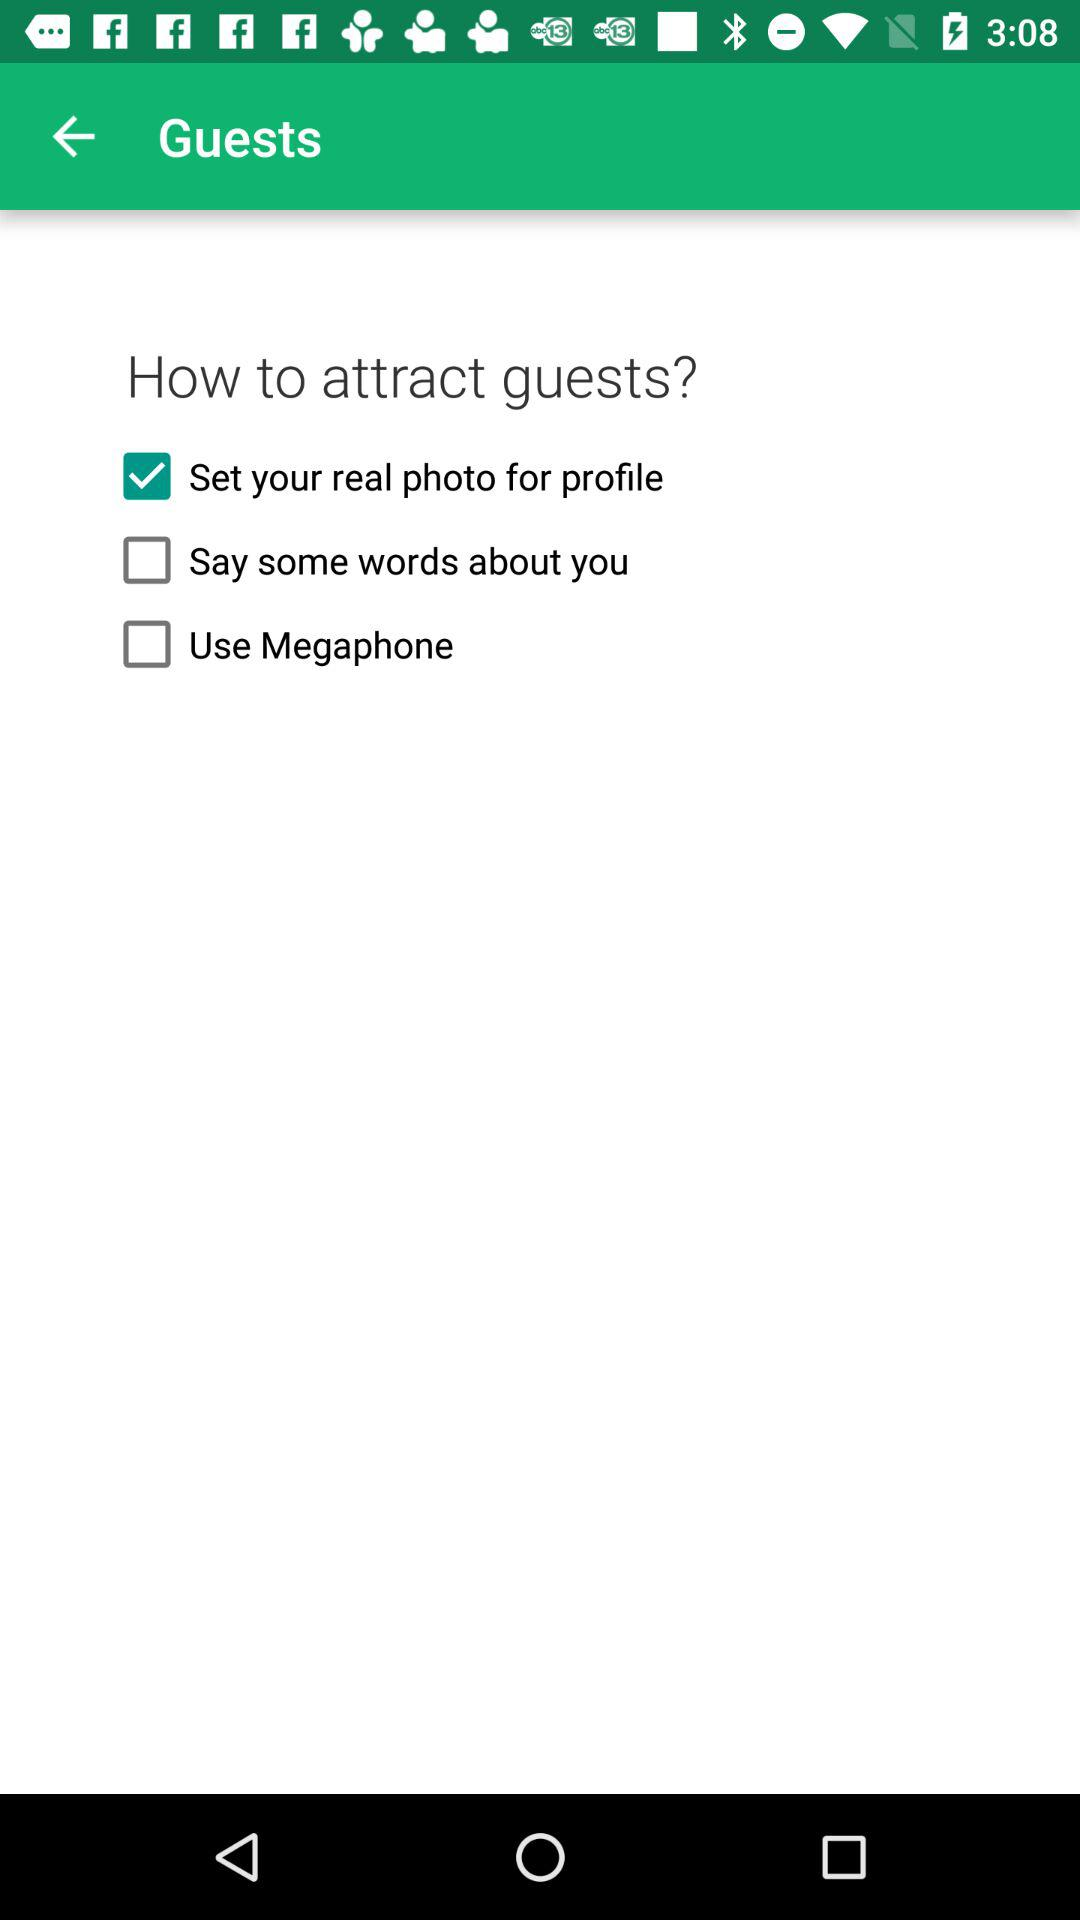How many checkbox labels are on the page?
Answer the question using a single word or phrase. 3 